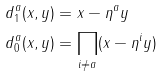Convert formula to latex. <formula><loc_0><loc_0><loc_500><loc_500>d ^ { a } _ { 1 } ( x , y ) & = x - \eta ^ { a } y \\ d ^ { a } _ { 0 } ( x , y ) & = \prod _ { i \neq a } ( x - \eta ^ { i } y )</formula> 